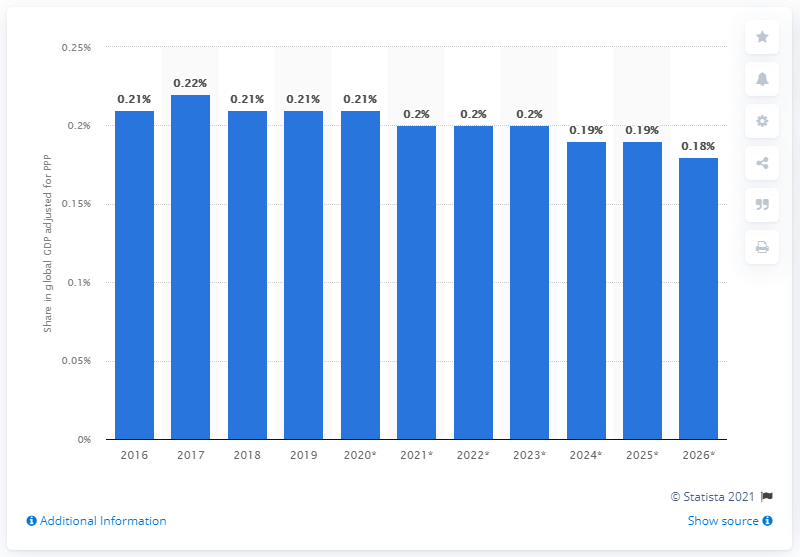Highlight a few significant elements in this photo. In 2019, Finland's share of the global gross domestic product, adjusted for Purchasing Power Parity, was 0.21%. 